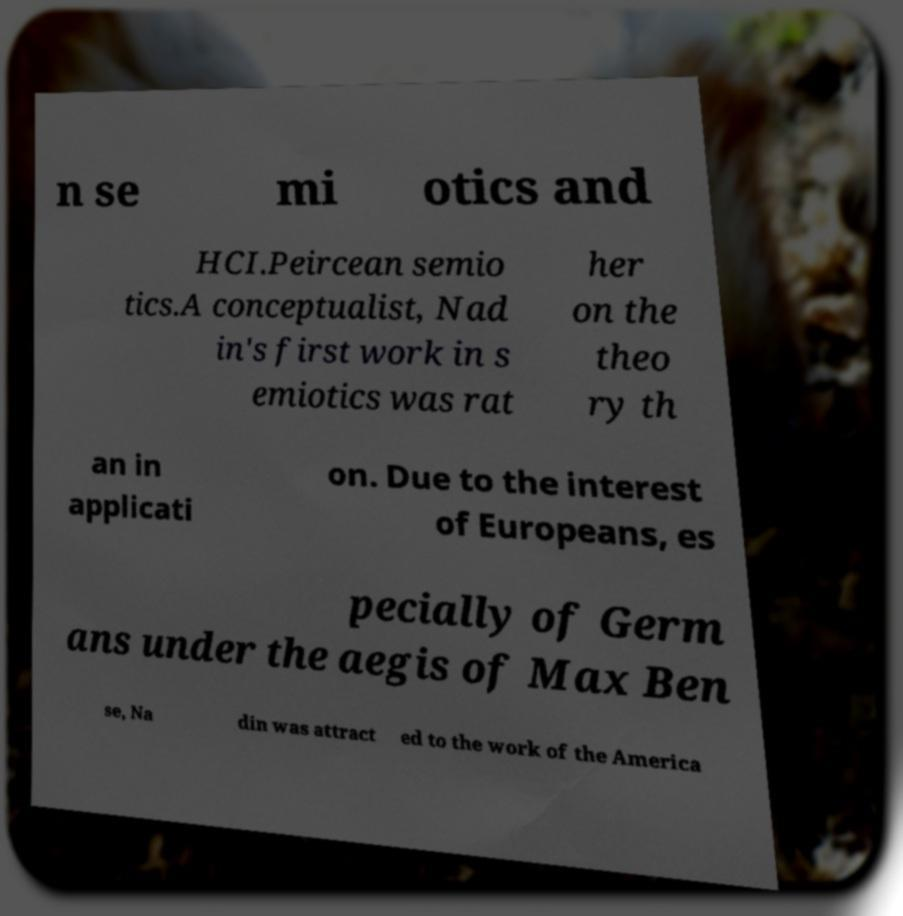What messages or text are displayed in this image? I need them in a readable, typed format. n se mi otics and HCI.Peircean semio tics.A conceptualist, Nad in's first work in s emiotics was rat her on the theo ry th an in applicati on. Due to the interest of Europeans, es pecially of Germ ans under the aegis of Max Ben se, Na din was attract ed to the work of the America 